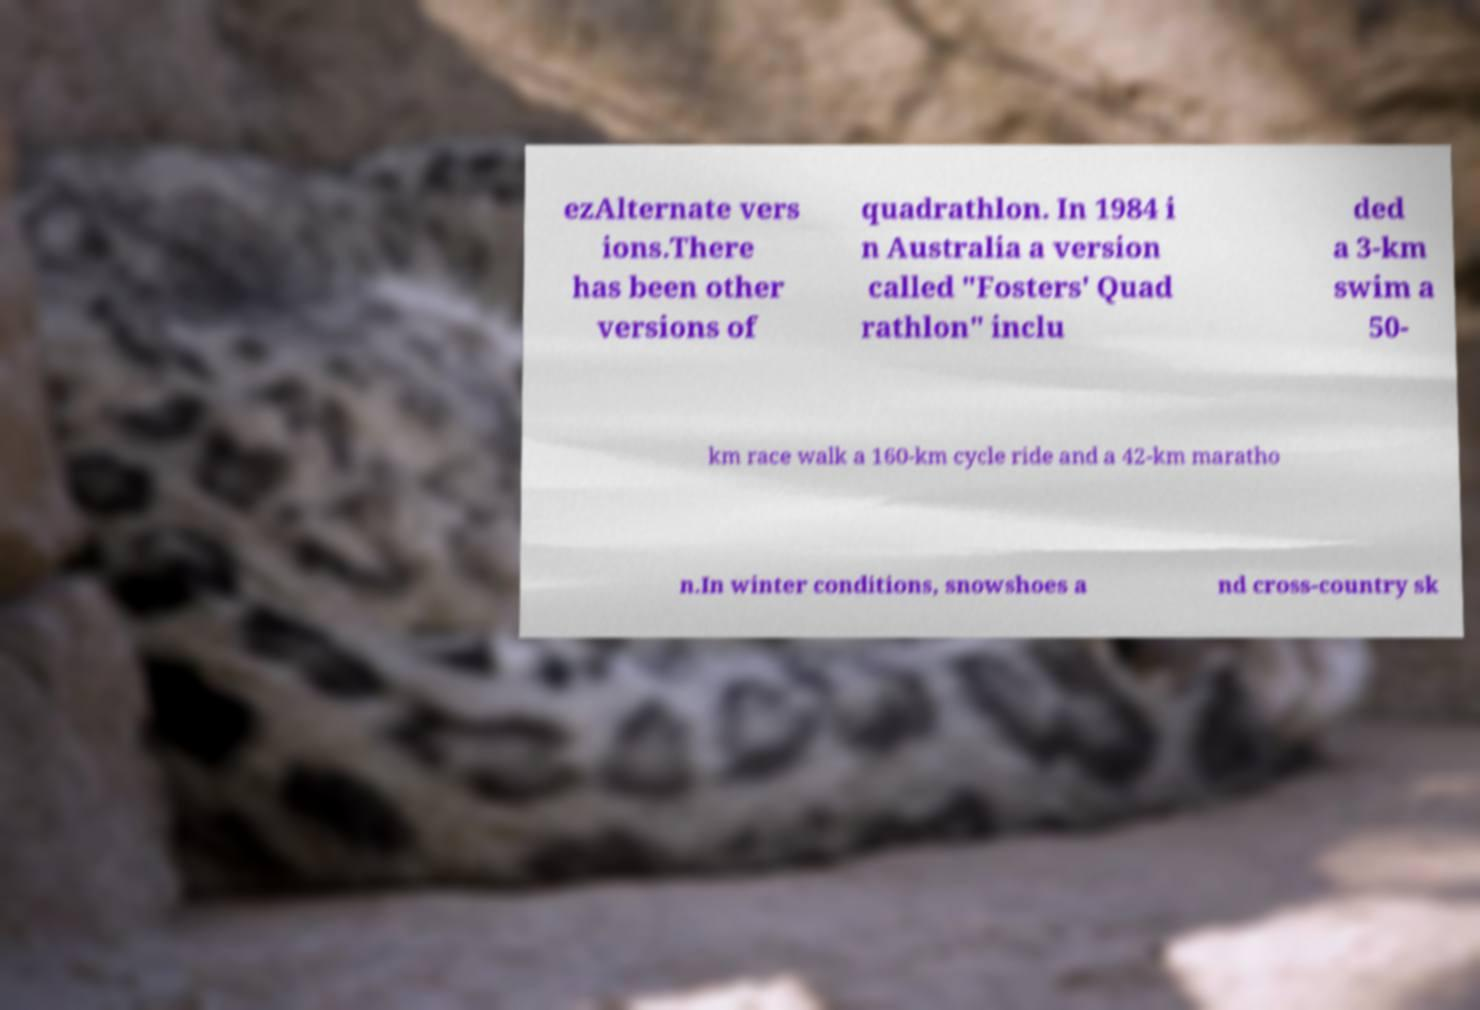Could you assist in decoding the text presented in this image and type it out clearly? ezAlternate vers ions.There has been other versions of quadrathlon. In 1984 i n Australia a version called "Fosters' Quad rathlon" inclu ded a 3-km swim a 50- km race walk a 160-km cycle ride and a 42-km maratho n.In winter conditions, snowshoes a nd cross-country sk 